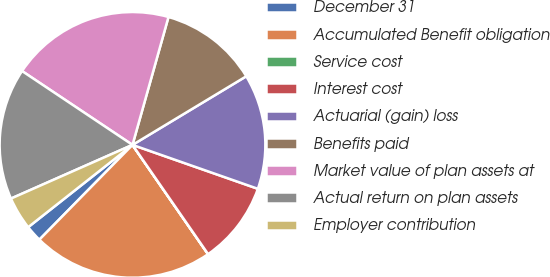<chart> <loc_0><loc_0><loc_500><loc_500><pie_chart><fcel>December 31<fcel>Accumulated Benefit obligation<fcel>Service cost<fcel>Interest cost<fcel>Actuarial (gain) loss<fcel>Benefits paid<fcel>Market value of plan assets at<fcel>Actual return on plan assets<fcel>Employer contribution<nl><fcel>2.01%<fcel>21.99%<fcel>0.01%<fcel>10.0%<fcel>14.0%<fcel>12.0%<fcel>19.99%<fcel>16.0%<fcel>4.01%<nl></chart> 